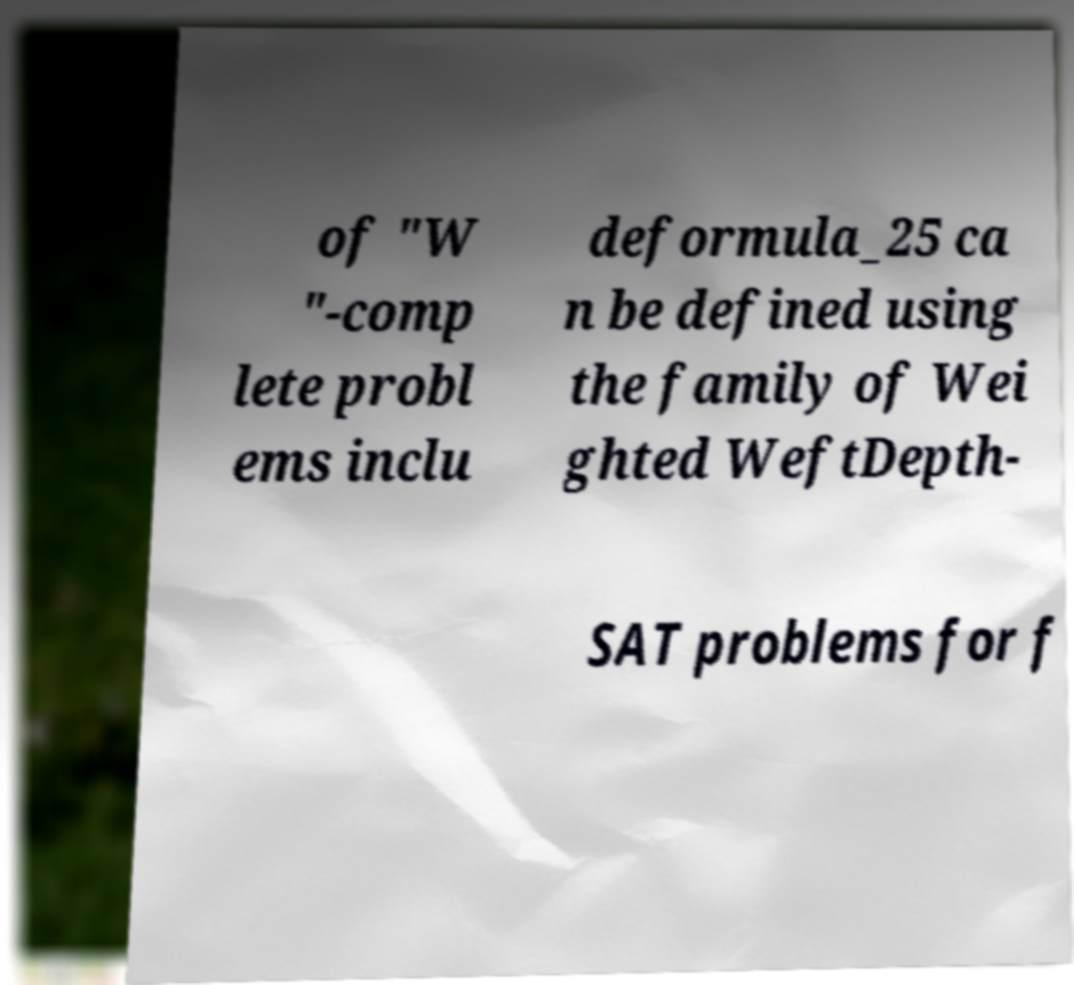Can you read and provide the text displayed in the image?This photo seems to have some interesting text. Can you extract and type it out for me? of "W "-comp lete probl ems inclu deformula_25 ca n be defined using the family of Wei ghted WeftDepth- SAT problems for f 